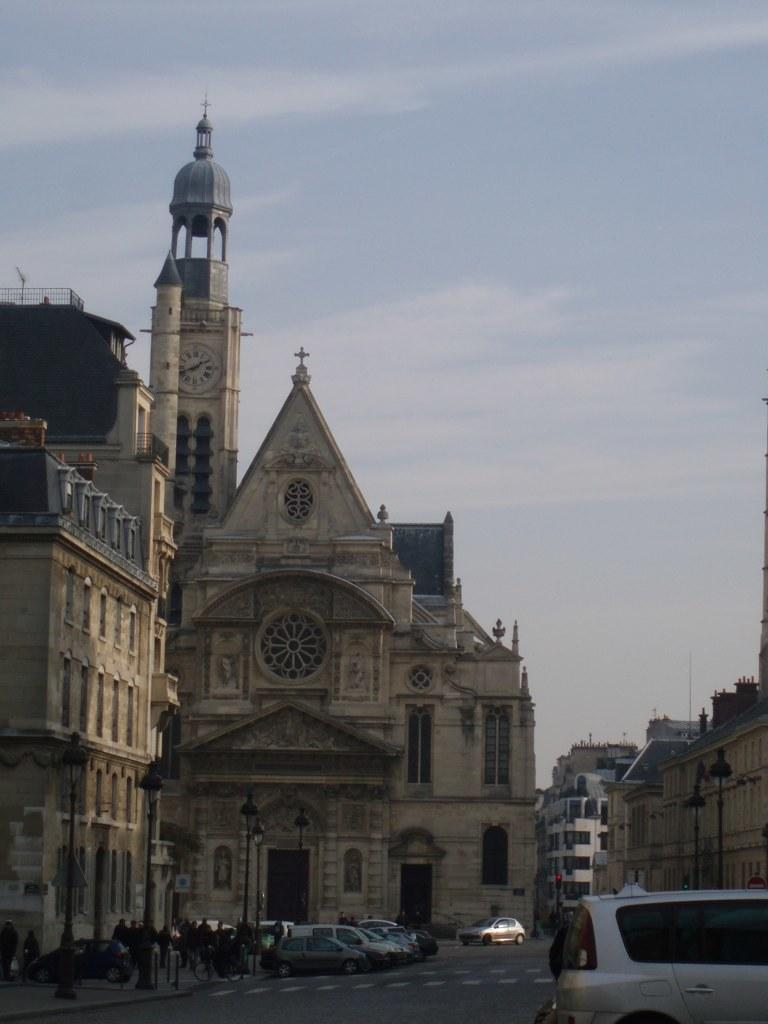What can be seen on the road in the image? There are vehicles on the road in the image. What is visible in the background of the image? There is a tall building in the background of the image. What is happening in front of the tall building? There are people standing in front of the tall building. Can you see a rabbit hopping near the tall building in the image? No, there is no rabbit present in the image. What type of ink is being used by the bee in the image? There is no bee or ink present in the image. 